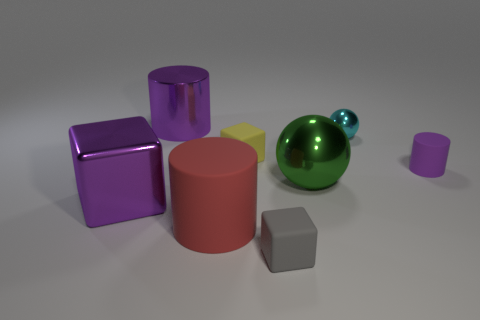Add 1 large gray cubes. How many objects exist? 9 Subtract all cubes. How many objects are left? 5 Add 1 small gray matte things. How many small gray matte things exist? 2 Subtract 0 gray cylinders. How many objects are left? 8 Subtract all large purple metal cylinders. Subtract all large objects. How many objects are left? 3 Add 3 large rubber cylinders. How many large rubber cylinders are left? 4 